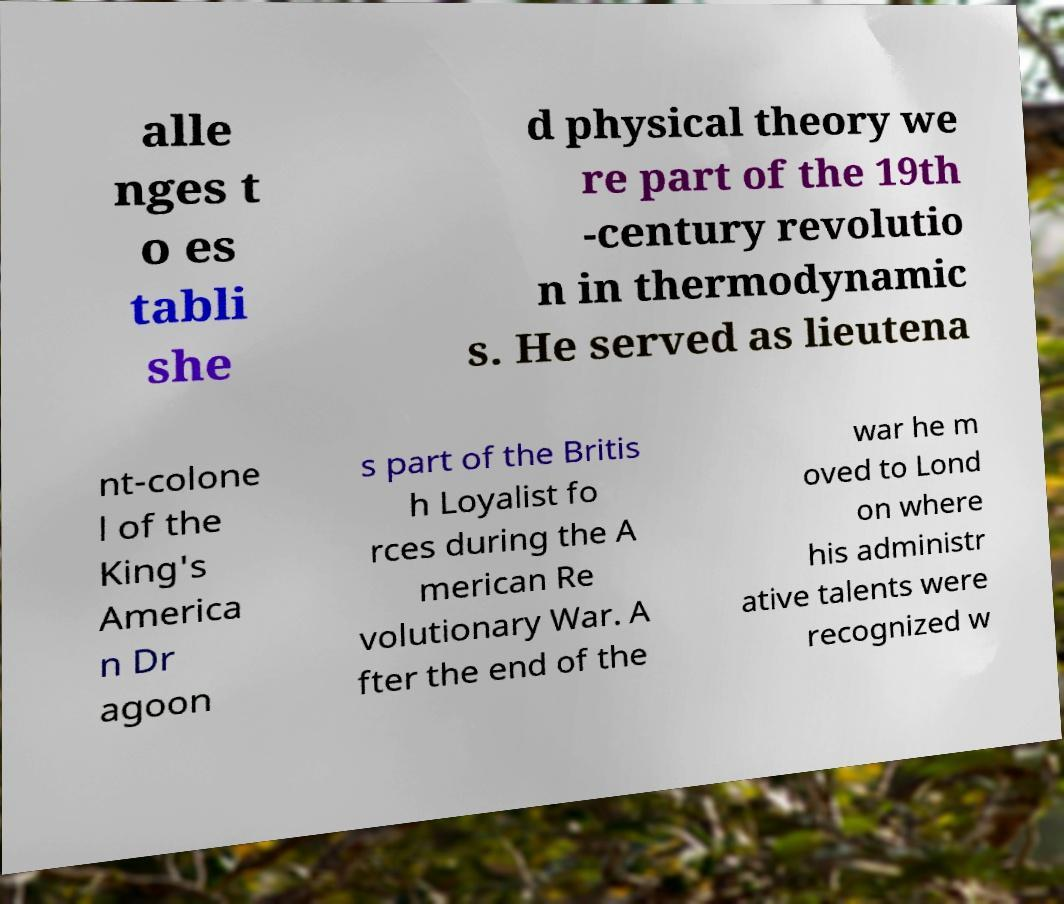What messages or text are displayed in this image? I need them in a readable, typed format. alle nges t o es tabli she d physical theory we re part of the 19th -century revolutio n in thermodynamic s. He served as lieutena nt-colone l of the King's America n Dr agoon s part of the Britis h Loyalist fo rces during the A merican Re volutionary War. A fter the end of the war he m oved to Lond on where his administr ative talents were recognized w 